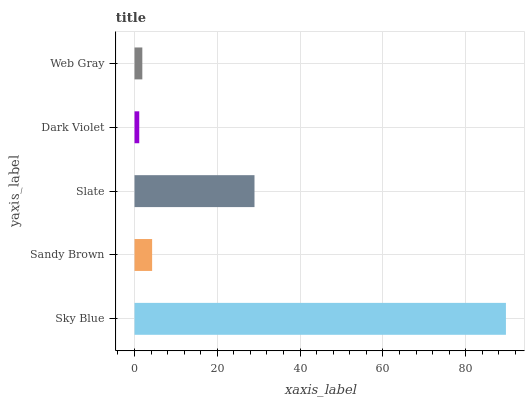Is Dark Violet the minimum?
Answer yes or no. Yes. Is Sky Blue the maximum?
Answer yes or no. Yes. Is Sandy Brown the minimum?
Answer yes or no. No. Is Sandy Brown the maximum?
Answer yes or no. No. Is Sky Blue greater than Sandy Brown?
Answer yes or no. Yes. Is Sandy Brown less than Sky Blue?
Answer yes or no. Yes. Is Sandy Brown greater than Sky Blue?
Answer yes or no. No. Is Sky Blue less than Sandy Brown?
Answer yes or no. No. Is Sandy Brown the high median?
Answer yes or no. Yes. Is Sandy Brown the low median?
Answer yes or no. Yes. Is Slate the high median?
Answer yes or no. No. Is Dark Violet the low median?
Answer yes or no. No. 